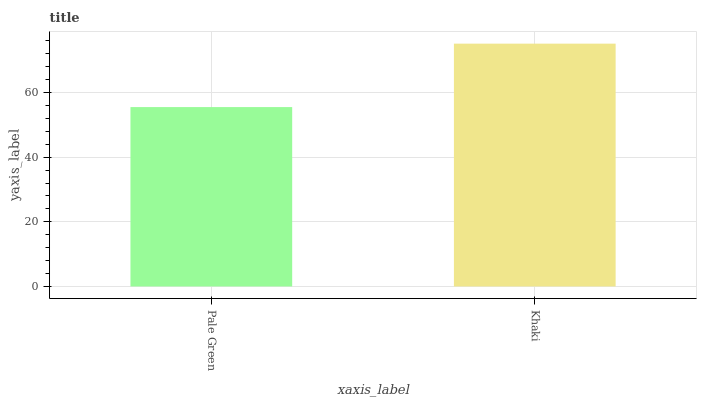Is Pale Green the minimum?
Answer yes or no. Yes. Is Khaki the maximum?
Answer yes or no. Yes. Is Khaki the minimum?
Answer yes or no. No. Is Khaki greater than Pale Green?
Answer yes or no. Yes. Is Pale Green less than Khaki?
Answer yes or no. Yes. Is Pale Green greater than Khaki?
Answer yes or no. No. Is Khaki less than Pale Green?
Answer yes or no. No. Is Khaki the high median?
Answer yes or no. Yes. Is Pale Green the low median?
Answer yes or no. Yes. Is Pale Green the high median?
Answer yes or no. No. Is Khaki the low median?
Answer yes or no. No. 